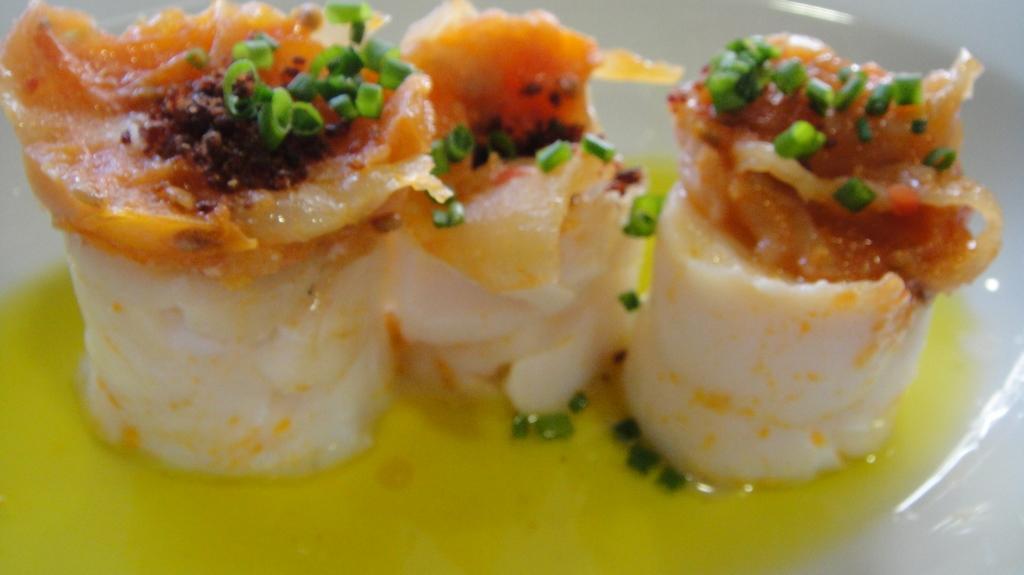Describe this image in one or two sentences. In this image, we can see some rolls which are very well garnished with orange in color and also some peas are present on them and all these rolls are dipped in the yolk. 